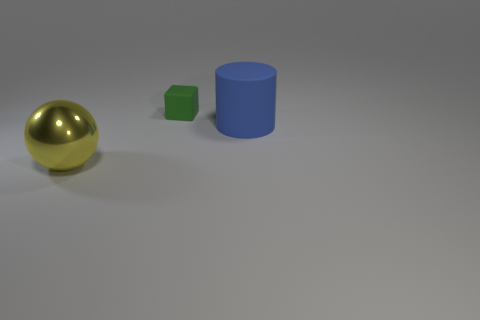Are there any other things that are the same color as the tiny rubber thing?
Ensure brevity in your answer.  No. Does the blue rubber object have the same size as the object that is to the left of the tiny green rubber block?
Make the answer very short. Yes. What number of other things are there of the same size as the block?
Give a very brief answer. 0. What shape is the big object that is right of the thing in front of the big thing that is behind the yellow metallic object?
Your answer should be very brief. Cylinder. What is the shape of the thing that is left of the big matte thing and in front of the tiny green rubber thing?
Provide a succinct answer. Sphere. How many things are red rubber objects or large objects that are to the right of the shiny sphere?
Provide a succinct answer. 1. Are the tiny thing and the sphere made of the same material?
Give a very brief answer. No. What number of other objects are there of the same shape as the big rubber thing?
Your answer should be very brief. 0. What size is the object that is both on the left side of the big cylinder and in front of the green rubber thing?
Provide a succinct answer. Large. What number of rubber objects are large gray balls or blue objects?
Your response must be concise. 1. 